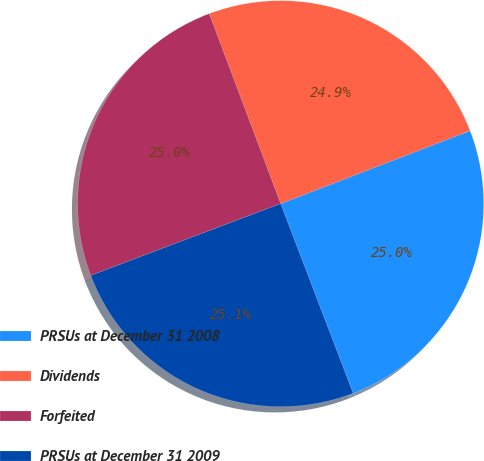<chart> <loc_0><loc_0><loc_500><loc_500><pie_chart><fcel>PRSUs at December 31 2008<fcel>Dividends<fcel>Forfeited<fcel>PRSUs at December 31 2009<nl><fcel>25.04%<fcel>24.87%<fcel>25.03%<fcel>25.06%<nl></chart> 